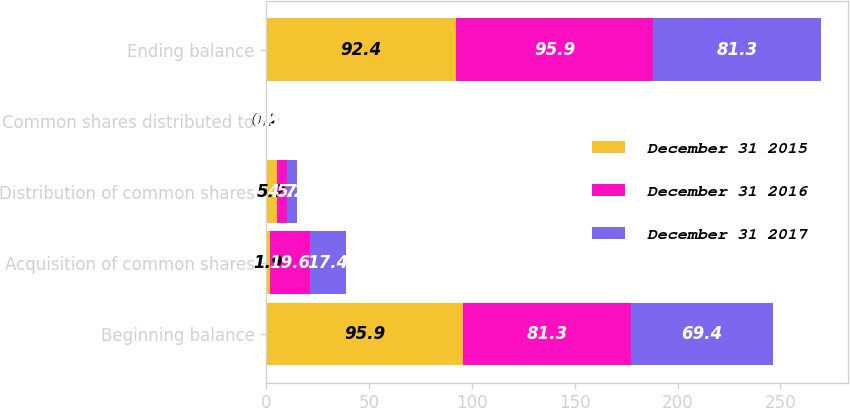<chart> <loc_0><loc_0><loc_500><loc_500><stacked_bar_chart><ecel><fcel>Beginning balance<fcel>Acquisition of common shares<fcel>Distribution of common shares<fcel>Common shares distributed to<fcel>Ending balance<nl><fcel>December 31 2015<fcel>95.9<fcel>1.9<fcel>5.2<fcel>0.2<fcel>92.4<nl><fcel>December 31 2016<fcel>81.3<fcel>19.6<fcel>4.7<fcel>0.3<fcel>95.9<nl><fcel>December 31 2017<fcel>69.4<fcel>17.4<fcel>5.2<fcel>0.1<fcel>81.3<nl></chart> 